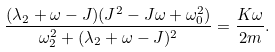Convert formula to latex. <formula><loc_0><loc_0><loc_500><loc_500>\frac { ( \lambda _ { 2 } + \omega - J ) ( J ^ { 2 } - J \omega + \omega _ { 0 } ^ { 2 } ) } { \omega _ { 2 } ^ { 2 } + ( \lambda _ { 2 } + \omega - J ) ^ { 2 } } = \frac { K \omega } { 2 m } .</formula> 